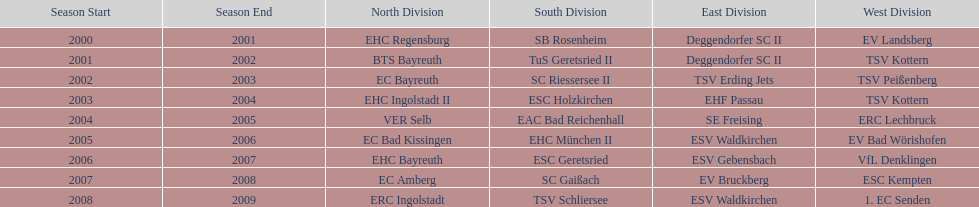Who won the south after esc geretsried did during the 2006-07 season? SC Gaißach. 